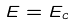<formula> <loc_0><loc_0><loc_500><loc_500>E = E _ { c }</formula> 